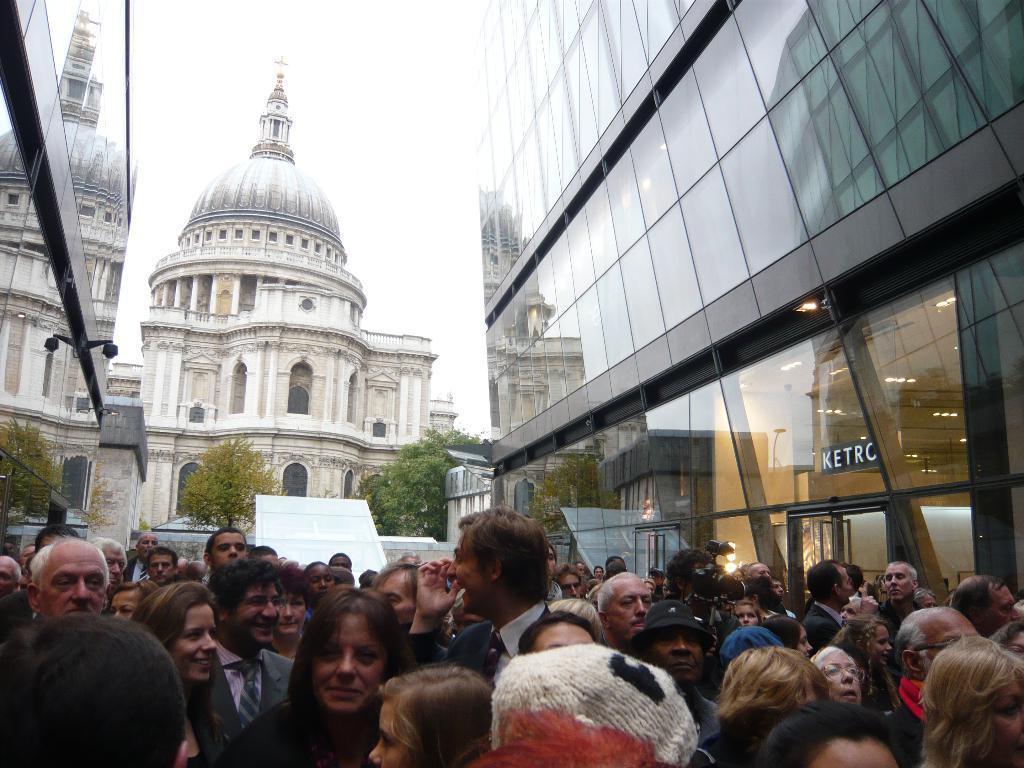Please provide a concise description of this image. This is the picture of a place where we have two buildings and some people in between the buildings and behind there is an other building and some trees. 